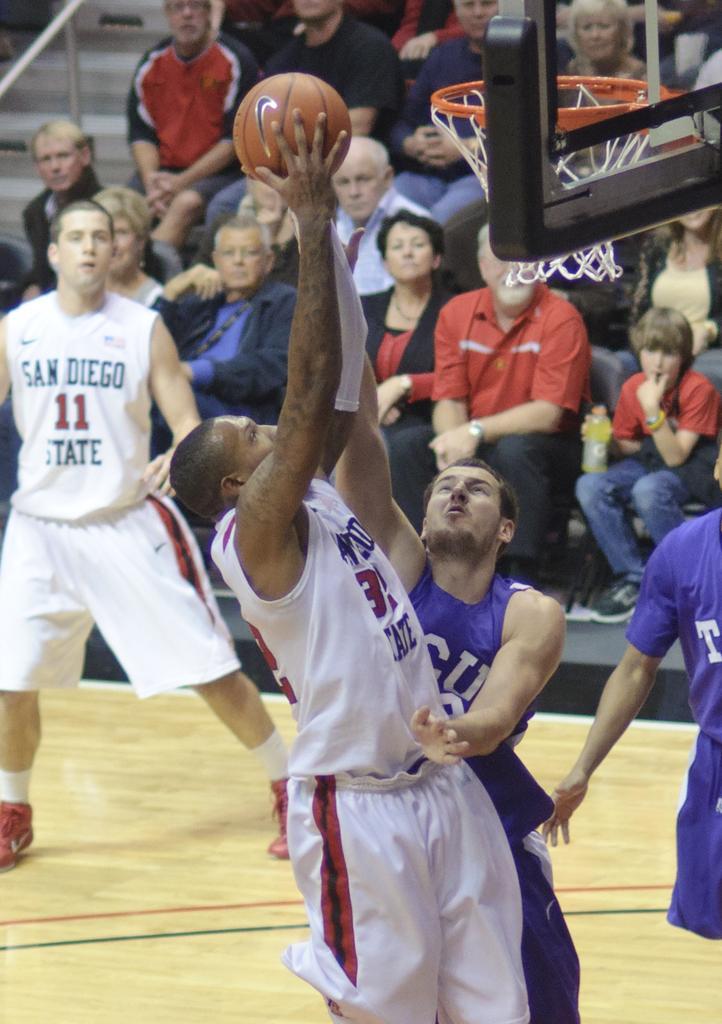Could you give a brief overview of what you see in this image? In the picture there are people playing with a ball, there are many people sitting and watching them. 